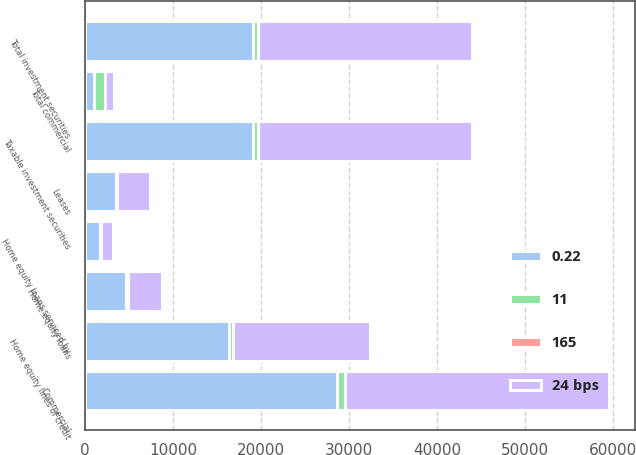Convert chart to OTSL. <chart><loc_0><loc_0><loc_500><loc_500><stacked_bar_chart><ecel><fcel>Taxable investment securities<fcel>Total investment securities<fcel>Commercial<fcel>Leases<fcel>Total commercial<fcel>Home equity loans<fcel>Home equity lines of credit<fcel>Home equity loans serviced by<nl><fcel>24 bps<fcel>24319<fcel>24330<fcel>29993<fcel>3776<fcel>1043<fcel>3877<fcel>15552<fcel>1352<nl><fcel>11<fcel>619<fcel>619<fcel>900<fcel>103<fcel>1186<fcel>205<fcel>450<fcel>91<nl><fcel>165<fcel>2.55<fcel>2.55<fcel>2.96<fcel>2.73<fcel>2.86<fcel>5.29<fcel>2.89<fcel>6.75<nl><fcel>0.22<fcel>19062<fcel>19074<fcel>28654<fcel>3463<fcel>1043<fcel>4606<fcel>16337<fcel>1724<nl></chart> 